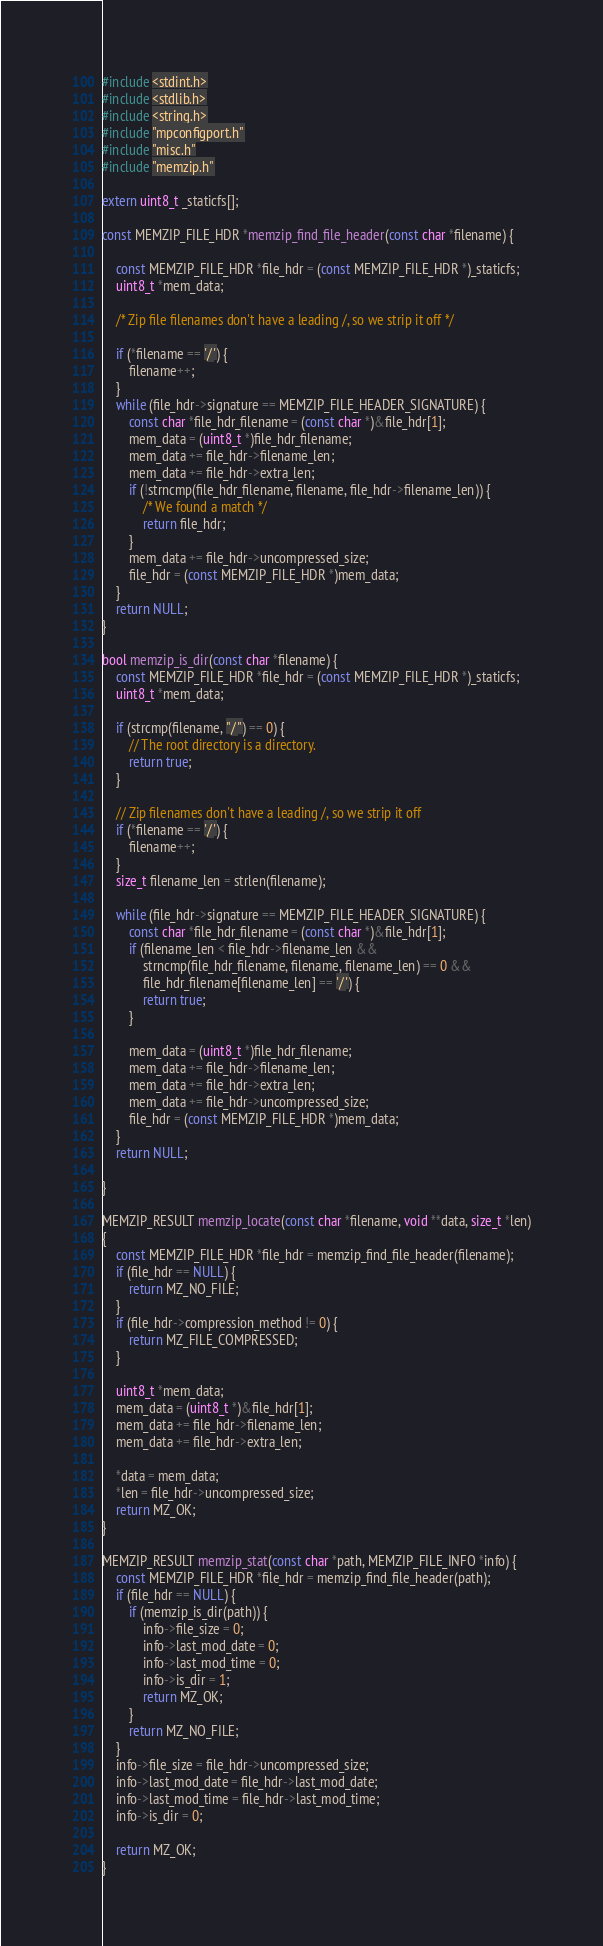Convert code to text. <code><loc_0><loc_0><loc_500><loc_500><_C_>#include <stdint.h>
#include <stdlib.h>
#include <string.h>
#include "mpconfigport.h"
#include "misc.h"
#include "memzip.h"

extern uint8_t _staticfs[];

const MEMZIP_FILE_HDR *memzip_find_file_header(const char *filename) {

    const MEMZIP_FILE_HDR *file_hdr = (const MEMZIP_FILE_HDR *)_staticfs;
    uint8_t *mem_data;

    /* Zip file filenames don't have a leading /, so we strip it off */

    if (*filename == '/') {
        filename++;
    }
    while (file_hdr->signature == MEMZIP_FILE_HEADER_SIGNATURE) {
        const char *file_hdr_filename = (const char *)&file_hdr[1];
        mem_data = (uint8_t *)file_hdr_filename;
        mem_data += file_hdr->filename_len;
        mem_data += file_hdr->extra_len;
        if (!strncmp(file_hdr_filename, filename, file_hdr->filename_len)) {
            /* We found a match */
            return file_hdr;
        }
        mem_data += file_hdr->uncompressed_size;
        file_hdr = (const MEMZIP_FILE_HDR *)mem_data;
    }
    return NULL;
}

bool memzip_is_dir(const char *filename) {
    const MEMZIP_FILE_HDR *file_hdr = (const MEMZIP_FILE_HDR *)_staticfs;
    uint8_t *mem_data;

    if (strcmp(filename, "/") == 0) {
        // The root directory is a directory.
        return true;
    }

    // Zip filenames don't have a leading /, so we strip it off
    if (*filename == '/') {
        filename++;
    }
    size_t filename_len = strlen(filename);

    while (file_hdr->signature == MEMZIP_FILE_HEADER_SIGNATURE) {
        const char *file_hdr_filename = (const char *)&file_hdr[1];
        if (filename_len < file_hdr->filename_len &&
            strncmp(file_hdr_filename, filename, filename_len) == 0 &&
            file_hdr_filename[filename_len] == '/') {
            return true;
        }

        mem_data = (uint8_t *)file_hdr_filename;
        mem_data += file_hdr->filename_len;
        mem_data += file_hdr->extra_len;
        mem_data += file_hdr->uncompressed_size;
        file_hdr = (const MEMZIP_FILE_HDR *)mem_data;
    }
    return NULL;

}

MEMZIP_RESULT memzip_locate(const char *filename, void **data, size_t *len)
{
    const MEMZIP_FILE_HDR *file_hdr = memzip_find_file_header(filename);
    if (file_hdr == NULL) {
        return MZ_NO_FILE;
    }
    if (file_hdr->compression_method != 0) {
        return MZ_FILE_COMPRESSED;
    }

    uint8_t *mem_data;
    mem_data = (uint8_t *)&file_hdr[1];
    mem_data += file_hdr->filename_len;
    mem_data += file_hdr->extra_len;

    *data = mem_data;
    *len = file_hdr->uncompressed_size;
    return MZ_OK;
}

MEMZIP_RESULT memzip_stat(const char *path, MEMZIP_FILE_INFO *info) {
    const MEMZIP_FILE_HDR *file_hdr = memzip_find_file_header(path);
    if (file_hdr == NULL) {
        if (memzip_is_dir(path)) {
            info->file_size = 0;
            info->last_mod_date = 0;
            info->last_mod_time = 0;
            info->is_dir = 1;
            return MZ_OK;
        }
        return MZ_NO_FILE;
    }
    info->file_size = file_hdr->uncompressed_size;
    info->last_mod_date = file_hdr->last_mod_date;
    info->last_mod_time = file_hdr->last_mod_time;
    info->is_dir = 0;

    return MZ_OK;
}
</code> 